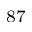<formula> <loc_0><loc_0><loc_500><loc_500>^ { 8 7 }</formula> 